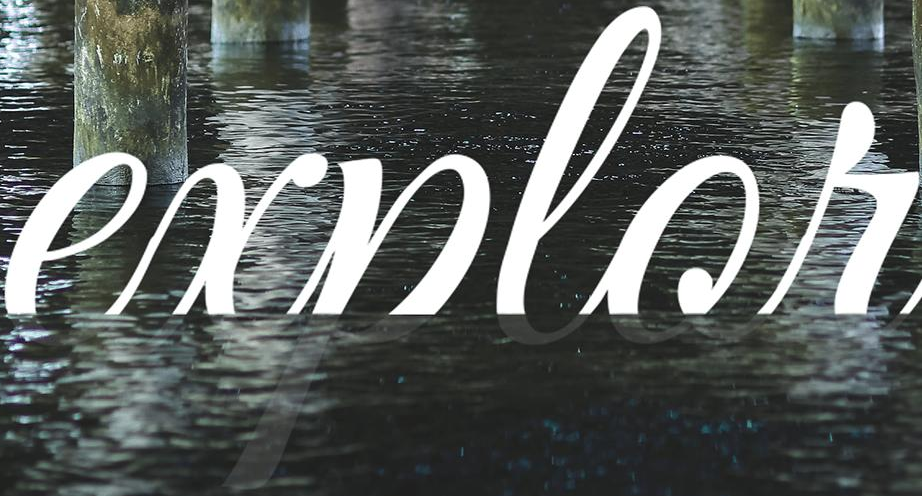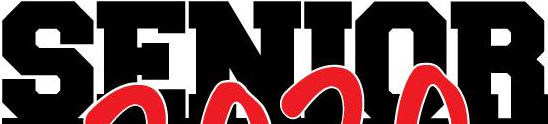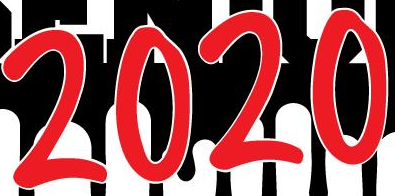What words are shown in these images in order, separated by a semicolon? explor; SENIOR; 2020 